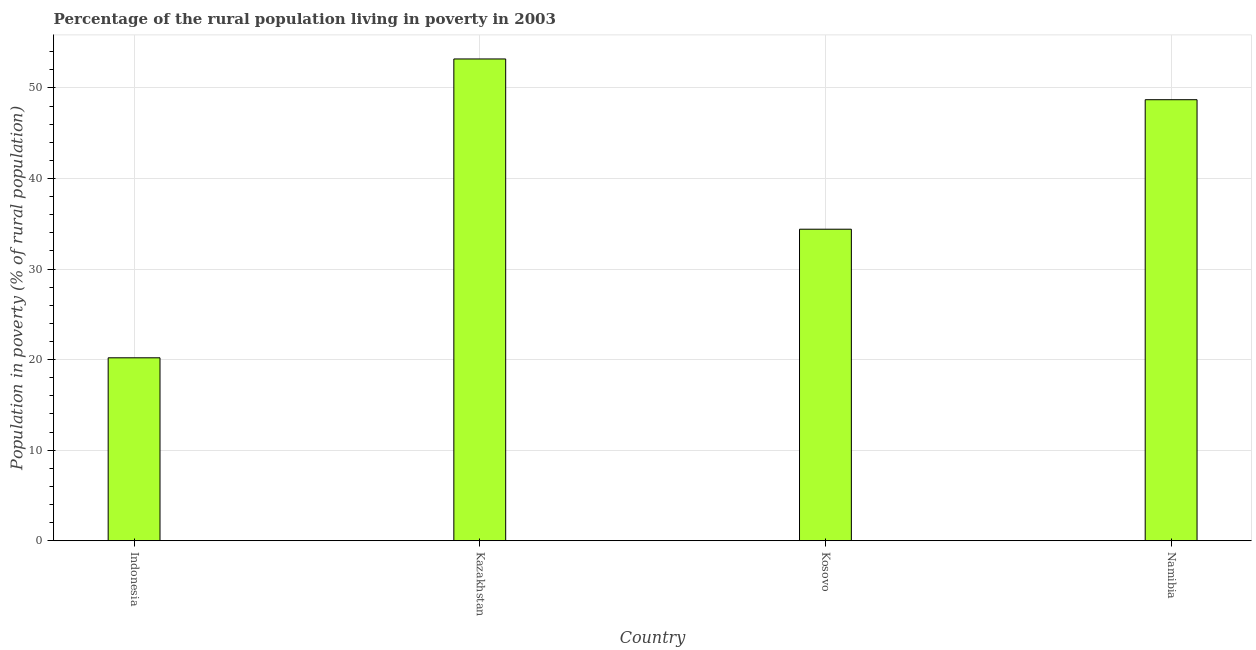Does the graph contain grids?
Your answer should be compact. Yes. What is the title of the graph?
Give a very brief answer. Percentage of the rural population living in poverty in 2003. What is the label or title of the X-axis?
Your answer should be compact. Country. What is the label or title of the Y-axis?
Your answer should be compact. Population in poverty (% of rural population). What is the percentage of rural population living below poverty line in Kazakhstan?
Ensure brevity in your answer.  53.2. Across all countries, what is the maximum percentage of rural population living below poverty line?
Keep it short and to the point. 53.2. Across all countries, what is the minimum percentage of rural population living below poverty line?
Ensure brevity in your answer.  20.2. In which country was the percentage of rural population living below poverty line maximum?
Give a very brief answer. Kazakhstan. What is the sum of the percentage of rural population living below poverty line?
Your response must be concise. 156.5. What is the difference between the percentage of rural population living below poverty line in Indonesia and Kazakhstan?
Provide a succinct answer. -33. What is the average percentage of rural population living below poverty line per country?
Ensure brevity in your answer.  39.12. What is the median percentage of rural population living below poverty line?
Keep it short and to the point. 41.55. In how many countries, is the percentage of rural population living below poverty line greater than 10 %?
Provide a succinct answer. 4. What is the ratio of the percentage of rural population living below poverty line in Kazakhstan to that in Namibia?
Give a very brief answer. 1.09. Is the percentage of rural population living below poverty line in Kosovo less than that in Namibia?
Offer a very short reply. Yes. Is the difference between the percentage of rural population living below poverty line in Indonesia and Kosovo greater than the difference between any two countries?
Ensure brevity in your answer.  No. What is the difference between the highest and the second highest percentage of rural population living below poverty line?
Give a very brief answer. 4.5. What is the difference between two consecutive major ticks on the Y-axis?
Ensure brevity in your answer.  10. Are the values on the major ticks of Y-axis written in scientific E-notation?
Offer a terse response. No. What is the Population in poverty (% of rural population) in Indonesia?
Your response must be concise. 20.2. What is the Population in poverty (% of rural population) in Kazakhstan?
Your answer should be very brief. 53.2. What is the Population in poverty (% of rural population) of Kosovo?
Give a very brief answer. 34.4. What is the Population in poverty (% of rural population) of Namibia?
Provide a short and direct response. 48.7. What is the difference between the Population in poverty (% of rural population) in Indonesia and Kazakhstan?
Your response must be concise. -33. What is the difference between the Population in poverty (% of rural population) in Indonesia and Namibia?
Provide a short and direct response. -28.5. What is the difference between the Population in poverty (% of rural population) in Kazakhstan and Namibia?
Offer a terse response. 4.5. What is the difference between the Population in poverty (% of rural population) in Kosovo and Namibia?
Offer a very short reply. -14.3. What is the ratio of the Population in poverty (% of rural population) in Indonesia to that in Kazakhstan?
Provide a short and direct response. 0.38. What is the ratio of the Population in poverty (% of rural population) in Indonesia to that in Kosovo?
Your answer should be compact. 0.59. What is the ratio of the Population in poverty (% of rural population) in Indonesia to that in Namibia?
Your answer should be very brief. 0.41. What is the ratio of the Population in poverty (% of rural population) in Kazakhstan to that in Kosovo?
Keep it short and to the point. 1.55. What is the ratio of the Population in poverty (% of rural population) in Kazakhstan to that in Namibia?
Your answer should be very brief. 1.09. What is the ratio of the Population in poverty (% of rural population) in Kosovo to that in Namibia?
Provide a succinct answer. 0.71. 